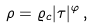<formula> <loc_0><loc_0><loc_500><loc_500>\rho = \varrho _ { c } | \tau | ^ { \varphi } \, ,</formula> 